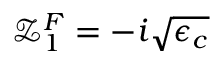Convert formula to latex. <formula><loc_0><loc_0><loc_500><loc_500>\mathcal { Z } _ { 1 } ^ { F } = - i \sqrt { \epsilon _ { c } }</formula> 